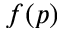Convert formula to latex. <formula><loc_0><loc_0><loc_500><loc_500>f ( p )</formula> 